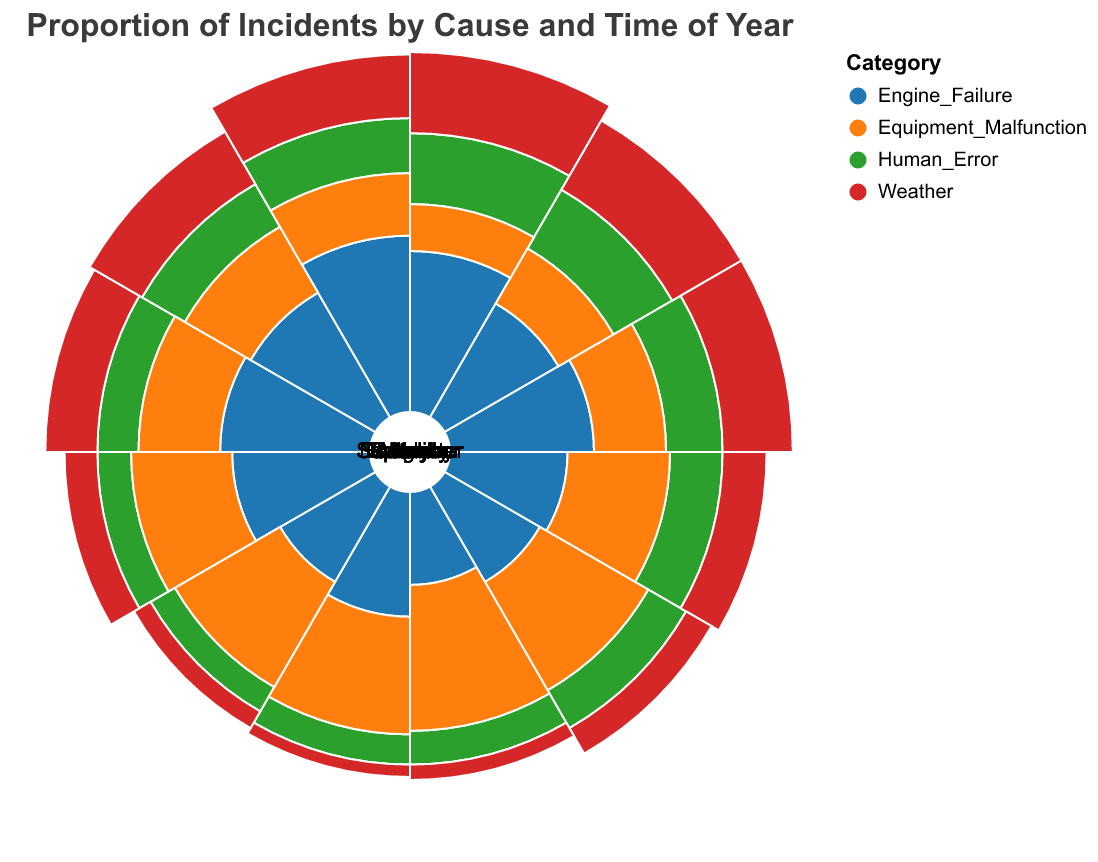What is the highest proportion of incidents caused by Engine Failure? The figure shows a polar chart where each segment represents a different proportion of incidents per cause and month. For Engine Failure, the segments show various proportions. The highest proportion for Engine Failure can be identified by noting the largest segment, which is in December with a proportion of 0.18.
Answer: 0.18 In which month does Human Error have the lowest proportion of incidents? To find the month with the lowest proportion of incidents for Human Error, we need to examine the segments for Human Error and identify the smallest one. This occurs in August, with a proportion of 0.08.
Answer: August How does the proportion of Weather-related incidents in July compare to those in January? For Weather-related incidents, we compare the proportion in July to that in January. July's proportion is 0.04, while January's is much higher at 0.30, showing January has a greater proportion of Weather-related incidents.
Answer: January has a greater proportion What is the overall trend in proportions of incidents caused by Equipment Malfunction from January to December? We observe the segments for Equipment Malfunction from January to December. There is a general increasing trend reaching its peak in June (0.28) and gradually decreasing afterward.
Answer: Increasing until June, then decreasing Which category has the most variable monthly proportions? To determine variability, we compare the range of proportions across months for each category. Weather's proportions fluctuate from 0.04 in July to 0.30 in January, the largest range, indicating Weather has the most variable monthly proportions.
Answer: Weather What's the average monthly proportion of incidents due to Equipment Malfunction? To calculate the average monthly proportion, sum the proportions for Equipment Malfunction across all months and divide by 12. The proportions are (0.10 + 0.12 + 0.15 + 0.20 + 0.25 + 0.28 + 0.25 + 0.24 + 0.22 + 0.18 + 0.16 + 0.15) = 2.3. Dividing by 12 gives 2.3/12 ≈ 0.192.
Answer: 0.192 In which months are Engine Failure incidents more frequent than Human Error incidents? We compare the proportions of Engine Failure and Human Error for each month. Engine Failure incidents are more frequent in July (0.09 vs 0.09), August (0.07 vs 0.08), September (0.11 vs 0.10), October (0.13 vs 0.12).
Answer: July, August, September, October Which month has the highest proportion of incidents regardless of cause? By examining all the segments, January has the highest individual proportion, which is related to Weather incidents at 0.30.
Answer: January 